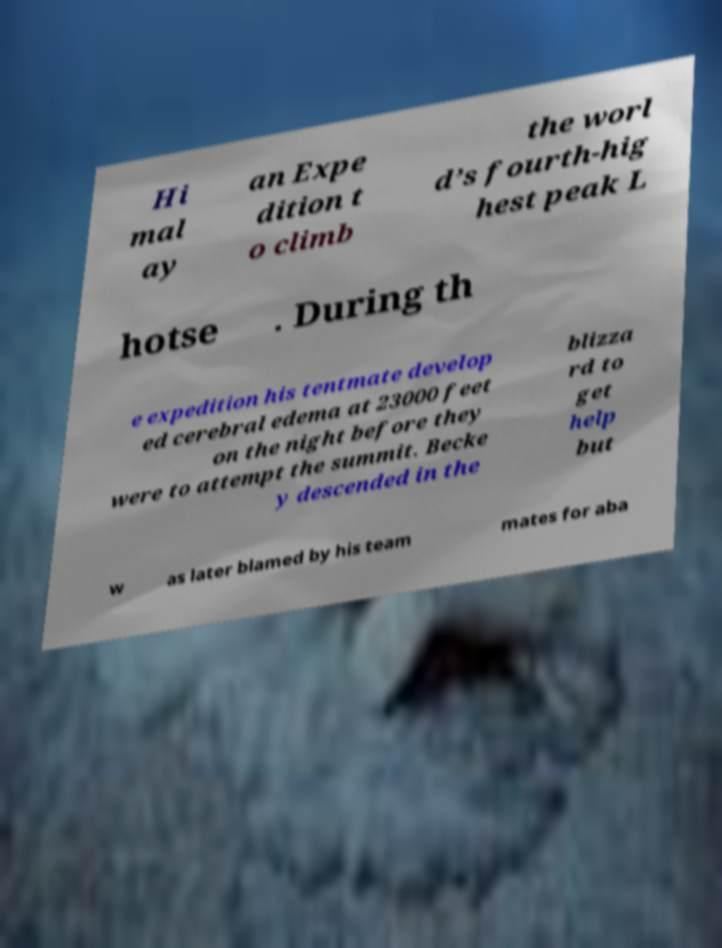I need the written content from this picture converted into text. Can you do that? Hi mal ay an Expe dition t o climb the worl d’s fourth-hig hest peak L hotse . During th e expedition his tentmate develop ed cerebral edema at 23000 feet on the night before they were to attempt the summit. Becke y descended in the blizza rd to get help but w as later blamed by his team mates for aba 